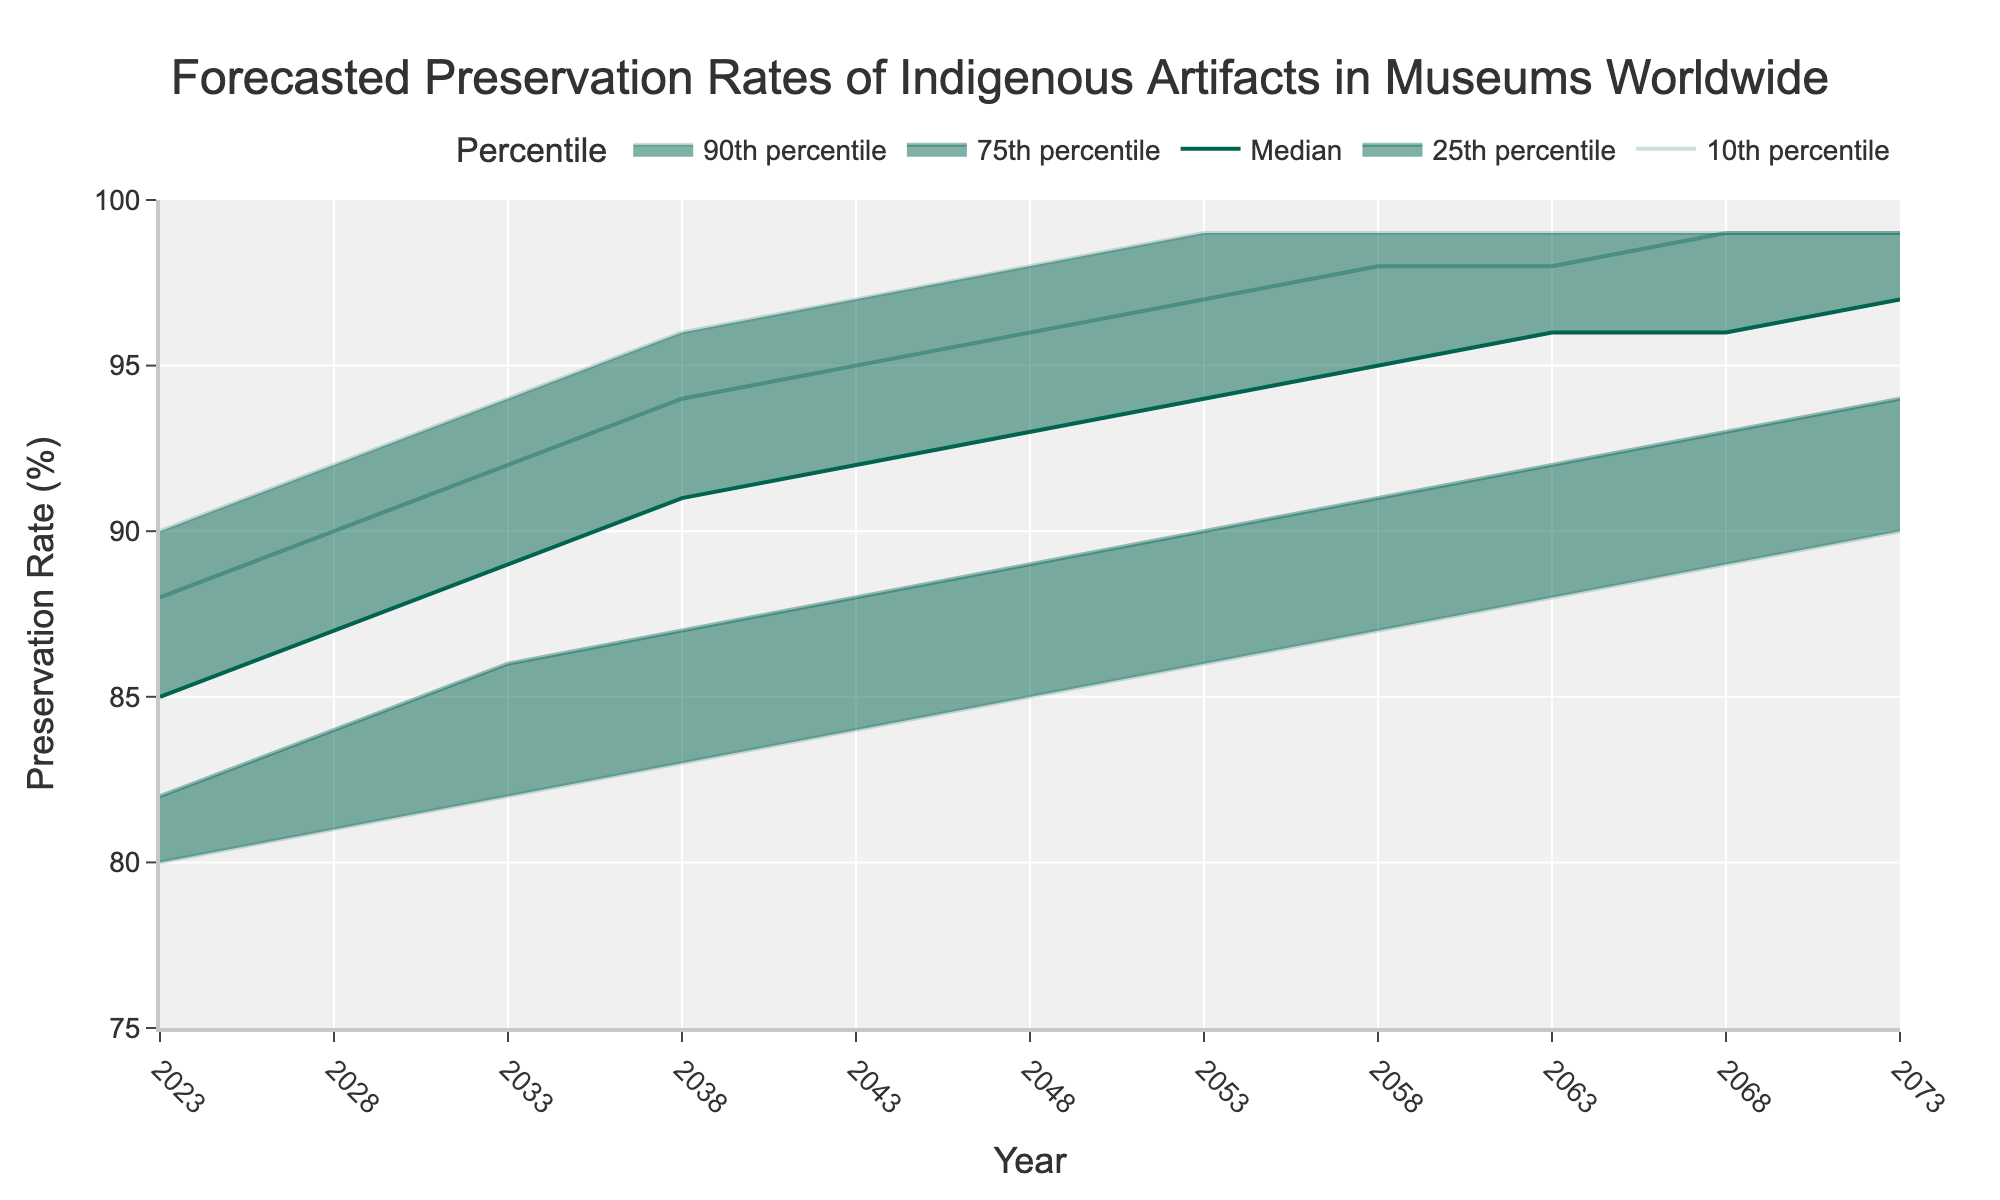What's the title of the figure? The title is typically found at the top of the figure and describes the content of the chart. In this case, it helps to understand what data is being presented.
Answer: Forecasted Preservation Rates of Indigenous Artifacts in Museums Worldwide What's the range of years presented on the x-axis? The x-axis displays the years, which in this case, span a specific period as indicated by the tick marks. Observing the initial and final tick marks gives the answer.
Answer: 2023 to 2073 In what year does the median preservation rate reach 94%? Locate the 'Median' line on the chart, follow it until it intersects with the 94% on the y-axis, and then trace vertically down to find the corresponding year on the x-axis.
Answer: 2053 What is the lowest 10th percentile preservation rate forecast for the year 2038? Identify the '10th percentile' line, find the point on this line corresponding to the year 2038, and read the value on the y-axis.
Answer: 83% How does the preservation rate gap between 10th percentile and 90th percentile change from 2023 to 2073? Compare the vertical distance between the 10th and 90th percentile lines at both the starting year (2023) and the ending year (2073). Calculate the difference for each year and compare these differences.
Answer: The gap decreases from 10 percentage points (2023: 80% to 90%) to 7 percentage points (2073: 90% to 99%) What are the preservation rates for the 25th and 75th percentiles in 2043? Find the 2043 year on the x-axis and trace vertically upwards to where it intersects the '25th percentile' and '75th percentile' lines. Read these values on the y-axis.
Answer: 88% (25th percentile) and 95% (75th percentile) What's the average median preservation rate forecast from 2023 to 2073? Add up all the median values from 2023 to 2073 and divide by the number of years. These values are 85, 87, 89, 91, 92, 93, 94, 95, 96, 96, 97 for 11 years. Sum = 1015; Average = 1015/11
Answer: 92.27% Between which years does the median preservation rate increase from 85% to 89%? Look at the 'Median' line and identify where it reaches 85% (2023) and then trace until it reaches 89%. Note the corresponding years from the x-axis.
Answer: 2023 to 2033 Which percentile shows the smallest increase in preservation rates from 2023 to 2073? Compare the beginning and ending percentage values of all the percentile lines (10th, 25th, 75th, 90th) and identify which has the smallest increase.
Answer: 90th percentile (increased by 9 percentage points from 90% to 99%) If you were to predict preservation rates for the year 2048, which percentile is likely to have the highest rate? Among the percentiles presented (10th, 25th, 50th (Median), 75th, 90th), the 90th percentile always shows the highest rate by design. Find the highest rate within these percentiles for 2048.
Answer: 90th percentile 